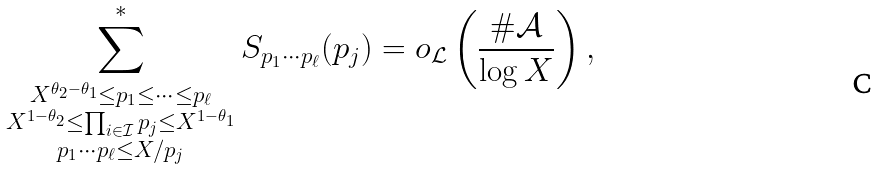<formula> <loc_0><loc_0><loc_500><loc_500>\sum _ { \substack { X ^ { \theta _ { 2 } - \theta _ { 1 } } \leq p _ { 1 } \leq \dots \leq p _ { \ell } \\ X ^ { 1 - \theta _ { 2 } } \leq \prod _ { i \in \mathcal { I } } p _ { j } \leq X ^ { 1 - \theta _ { 1 } } \\ p _ { 1 } \cdots p _ { \ell } \leq X / p _ { j } } } ^ { * } S _ { p _ { 1 } \cdots p _ { \ell } } ( p _ { j } ) = o _ { \mathcal { L } } \left ( \frac { \# \mathcal { A } } { \log { X } } \right ) ,</formula> 